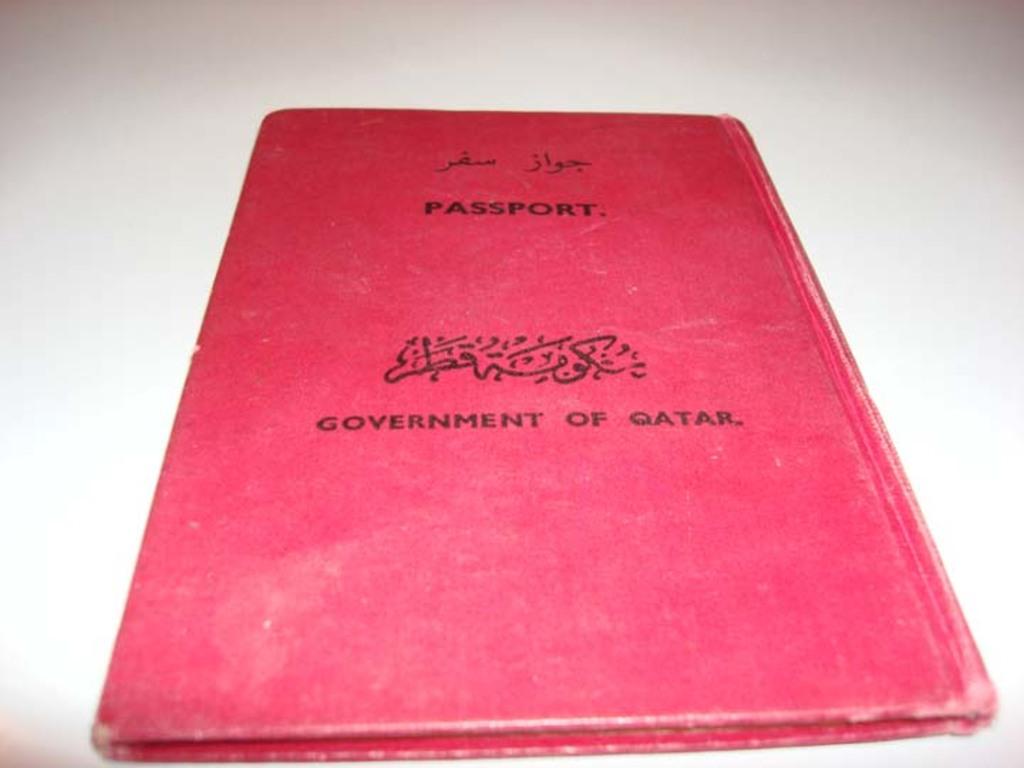What government document can i use this for?
Make the answer very short. Passport. What type of document is this?
Make the answer very short. Passport. 